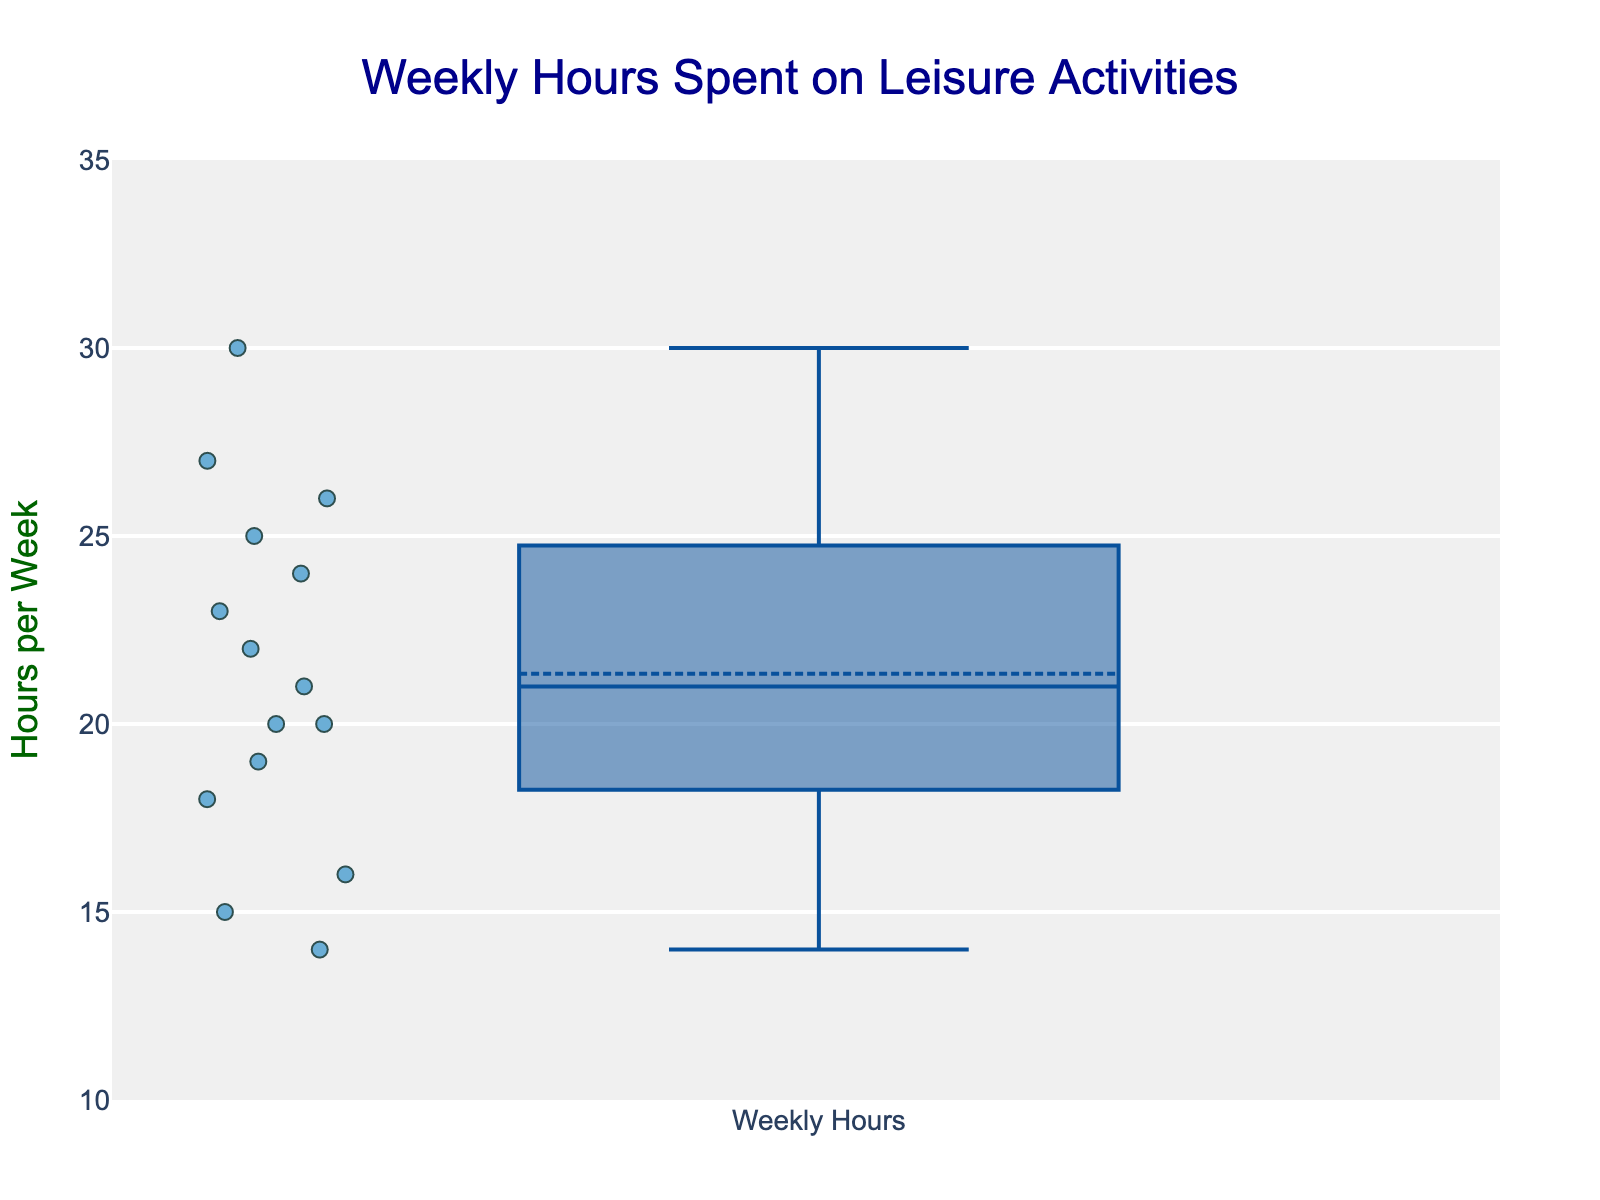How many data points are shown in the box plot? There are individual points marked on the box plot. Simply count these data points to find the total number.
Answer: 15 What is the median weekly hours spent on leisure activities? The median is represented by the line within the box. Estimate the value of this line on the y-axis.
Answer: 21 What is the interquartile range (IQR) of the weekly hours? The IQR is the range between the first quartile (25th percentile) and the third quartile (75th percentile). Identify these values on the box plot and subtract the first quartile from the third quartile.
Answer: 6 (IQR = Q3 - Q1 which is approximately 24 - 18) Which data point represents the lowest value in the distribution? Identify the individual data point at the bottom of the plot. This is the minimum value.
Answer: 14 Is the mean higher or lower than the median in this distribution? The mean is shown as a distinct point, often marked as a small circle within the box plot. Compare this value with the median line.
Answer: Higher Are there any outliers in the box plot? Outliers are individual points that fall outside the whiskers of the box plot. Look for points that are distinctly isolated from the main cluster of data.
Answer: No What is the range of the weekly hours spent on leisure activities? The range is the difference between the maximum and minimum values. Identify these extreme points on the plot and subtract the minimum value from the maximum value.
Answer: 16 (range = max - min which is 30 - 14) How many individuals spend more than 25 hours per week on leisure activities? Count the number of data points that are above the 25-hour mark on the y-axis.
Answer: 4 